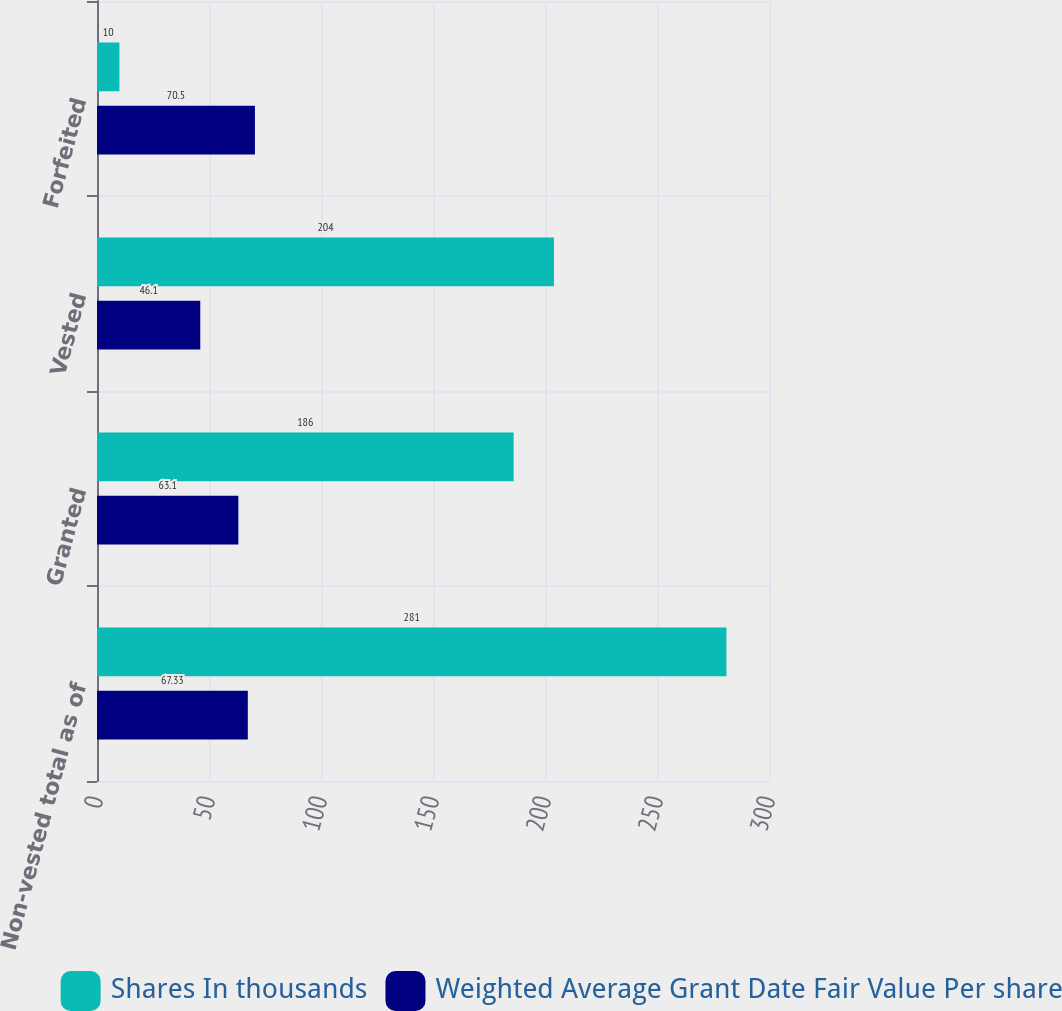<chart> <loc_0><loc_0><loc_500><loc_500><stacked_bar_chart><ecel><fcel>Non-vested total as of<fcel>Granted<fcel>Vested<fcel>Forfeited<nl><fcel>Shares In thousands<fcel>281<fcel>186<fcel>204<fcel>10<nl><fcel>Weighted Average Grant Date Fair Value Per share<fcel>67.33<fcel>63.1<fcel>46.1<fcel>70.5<nl></chart> 